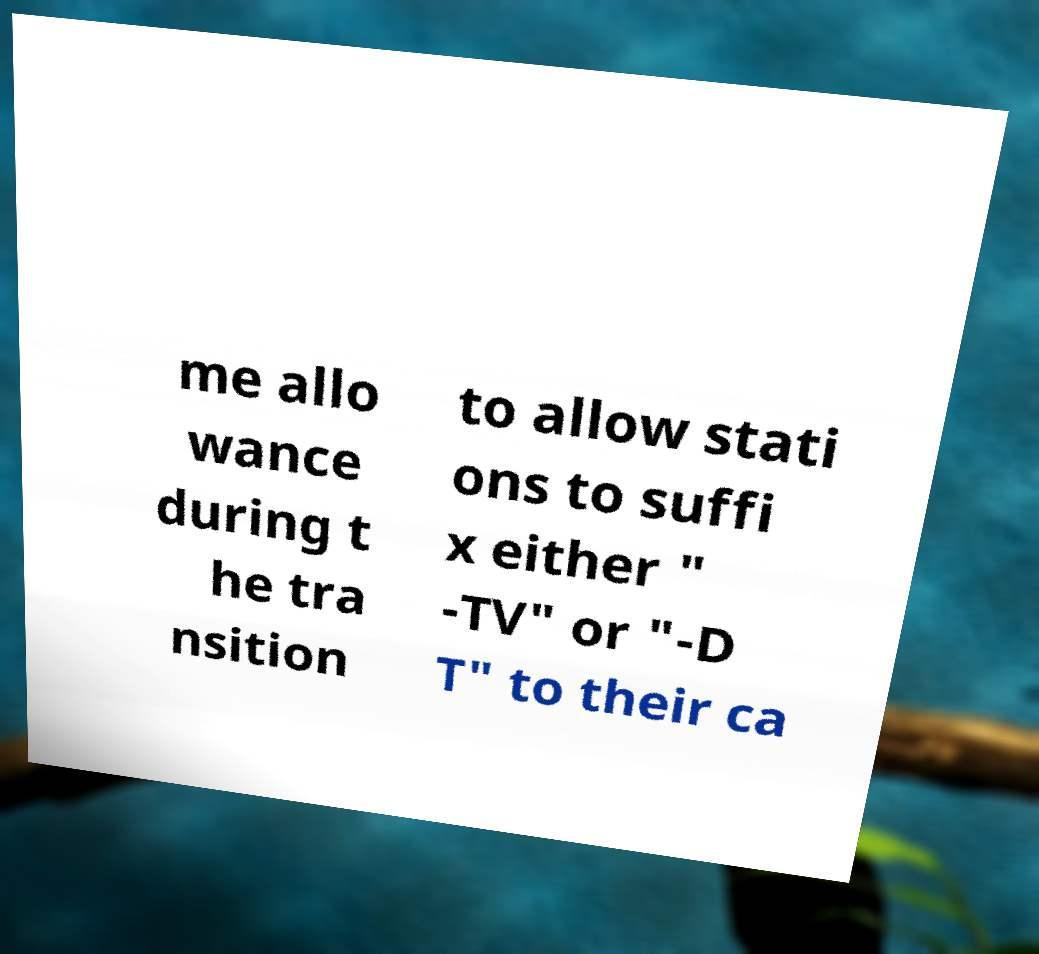What messages or text are displayed in this image? I need them in a readable, typed format. me allo wance during t he tra nsition to allow stati ons to suffi x either " -TV" or "-D T" to their ca 